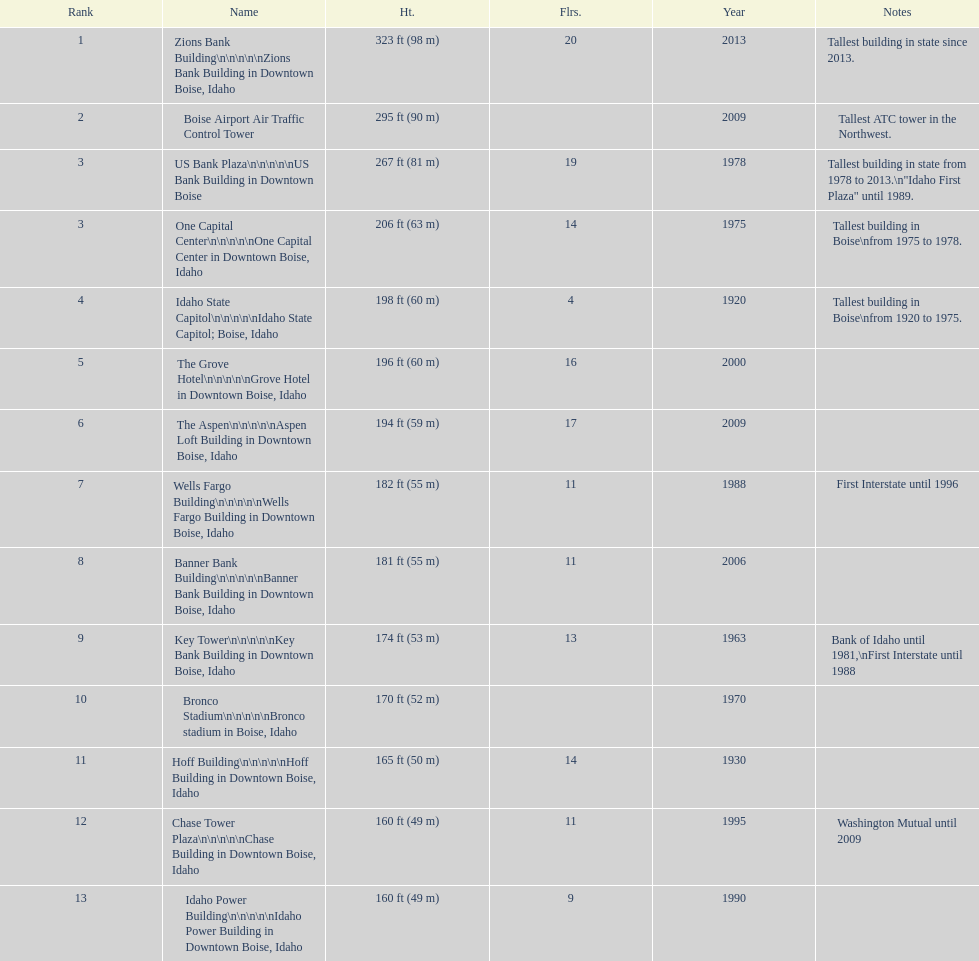What is the number of buildings constructed post-1975? 8. 